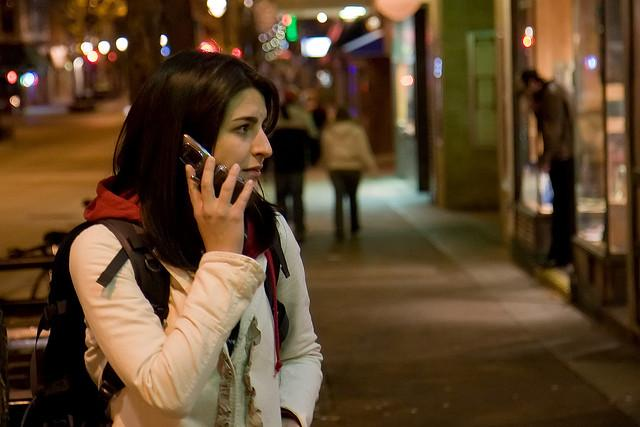What type of city district is this? shopping 